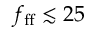<formula> <loc_0><loc_0><loc_500><loc_500>f _ { f f } \lesssim 2 5</formula> 